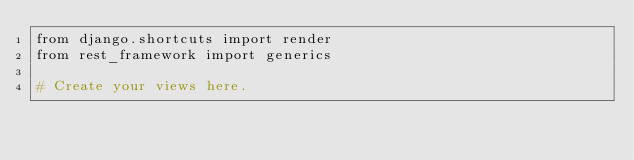Convert code to text. <code><loc_0><loc_0><loc_500><loc_500><_Python_>from django.shortcuts import render
from rest_framework import generics

# Create your views here.
</code> 